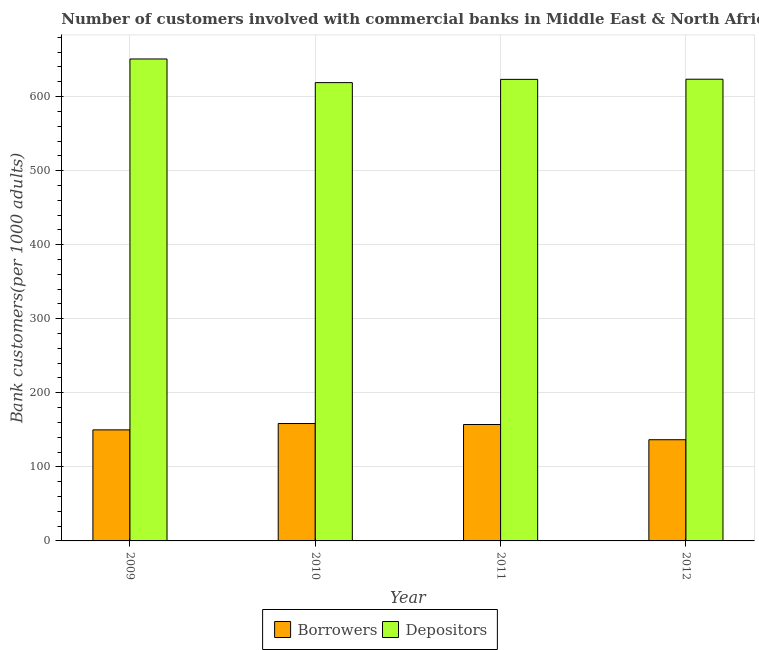Are the number of bars per tick equal to the number of legend labels?
Give a very brief answer. Yes. How many bars are there on the 1st tick from the right?
Give a very brief answer. 2. What is the label of the 3rd group of bars from the left?
Give a very brief answer. 2011. In how many cases, is the number of bars for a given year not equal to the number of legend labels?
Offer a terse response. 0. What is the number of borrowers in 2012?
Provide a short and direct response. 136.65. Across all years, what is the maximum number of borrowers?
Provide a short and direct response. 158.51. Across all years, what is the minimum number of depositors?
Provide a short and direct response. 618.84. What is the total number of borrowers in the graph?
Your answer should be very brief. 602.31. What is the difference between the number of borrowers in 2009 and that in 2011?
Your answer should be very brief. -7.25. What is the difference between the number of borrowers in 2012 and the number of depositors in 2010?
Give a very brief answer. -21.87. What is the average number of depositors per year?
Ensure brevity in your answer.  629.07. In the year 2010, what is the difference between the number of depositors and number of borrowers?
Keep it short and to the point. 0. What is the ratio of the number of depositors in 2010 to that in 2011?
Provide a succinct answer. 0.99. Is the number of borrowers in 2009 less than that in 2012?
Provide a succinct answer. No. Is the difference between the number of borrowers in 2010 and 2011 greater than the difference between the number of depositors in 2010 and 2011?
Offer a very short reply. No. What is the difference between the highest and the second highest number of depositors?
Your answer should be very brief. 27.32. What is the difference between the highest and the lowest number of borrowers?
Your answer should be very brief. 21.87. What does the 1st bar from the left in 2011 represents?
Provide a succinct answer. Borrowers. What does the 2nd bar from the right in 2010 represents?
Your answer should be compact. Borrowers. How many bars are there?
Offer a terse response. 8. What is the difference between two consecutive major ticks on the Y-axis?
Your answer should be very brief. 100. Are the values on the major ticks of Y-axis written in scientific E-notation?
Keep it short and to the point. No. Where does the legend appear in the graph?
Provide a short and direct response. Bottom center. What is the title of the graph?
Ensure brevity in your answer.  Number of customers involved with commercial banks in Middle East & North Africa (all income levels). Does "Highest 10% of population" appear as one of the legend labels in the graph?
Provide a succinct answer. No. What is the label or title of the Y-axis?
Your answer should be very brief. Bank customers(per 1000 adults). What is the Bank customers(per 1000 adults) of Borrowers in 2009?
Provide a succinct answer. 149.95. What is the Bank customers(per 1000 adults) in Depositors in 2009?
Offer a very short reply. 650.77. What is the Bank customers(per 1000 adults) in Borrowers in 2010?
Your answer should be very brief. 158.51. What is the Bank customers(per 1000 adults) of Depositors in 2010?
Provide a short and direct response. 618.84. What is the Bank customers(per 1000 adults) in Borrowers in 2011?
Your response must be concise. 157.2. What is the Bank customers(per 1000 adults) in Depositors in 2011?
Offer a very short reply. 623.22. What is the Bank customers(per 1000 adults) of Borrowers in 2012?
Your answer should be compact. 136.65. What is the Bank customers(per 1000 adults) in Depositors in 2012?
Provide a succinct answer. 623.45. Across all years, what is the maximum Bank customers(per 1000 adults) in Borrowers?
Ensure brevity in your answer.  158.51. Across all years, what is the maximum Bank customers(per 1000 adults) of Depositors?
Ensure brevity in your answer.  650.77. Across all years, what is the minimum Bank customers(per 1000 adults) of Borrowers?
Make the answer very short. 136.65. Across all years, what is the minimum Bank customers(per 1000 adults) of Depositors?
Offer a very short reply. 618.84. What is the total Bank customers(per 1000 adults) in Borrowers in the graph?
Offer a terse response. 602.31. What is the total Bank customers(per 1000 adults) of Depositors in the graph?
Your answer should be compact. 2516.28. What is the difference between the Bank customers(per 1000 adults) of Borrowers in 2009 and that in 2010?
Provide a succinct answer. -8.56. What is the difference between the Bank customers(per 1000 adults) in Depositors in 2009 and that in 2010?
Keep it short and to the point. 31.92. What is the difference between the Bank customers(per 1000 adults) in Borrowers in 2009 and that in 2011?
Offer a very short reply. -7.25. What is the difference between the Bank customers(per 1000 adults) in Depositors in 2009 and that in 2011?
Your answer should be very brief. 27.55. What is the difference between the Bank customers(per 1000 adults) in Borrowers in 2009 and that in 2012?
Your response must be concise. 13.3. What is the difference between the Bank customers(per 1000 adults) in Depositors in 2009 and that in 2012?
Ensure brevity in your answer.  27.32. What is the difference between the Bank customers(per 1000 adults) in Borrowers in 2010 and that in 2011?
Offer a very short reply. 1.32. What is the difference between the Bank customers(per 1000 adults) in Depositors in 2010 and that in 2011?
Your response must be concise. -4.38. What is the difference between the Bank customers(per 1000 adults) of Borrowers in 2010 and that in 2012?
Your answer should be compact. 21.87. What is the difference between the Bank customers(per 1000 adults) of Depositors in 2010 and that in 2012?
Your answer should be very brief. -4.61. What is the difference between the Bank customers(per 1000 adults) in Borrowers in 2011 and that in 2012?
Provide a short and direct response. 20.55. What is the difference between the Bank customers(per 1000 adults) in Depositors in 2011 and that in 2012?
Provide a succinct answer. -0.23. What is the difference between the Bank customers(per 1000 adults) in Borrowers in 2009 and the Bank customers(per 1000 adults) in Depositors in 2010?
Ensure brevity in your answer.  -468.89. What is the difference between the Bank customers(per 1000 adults) in Borrowers in 2009 and the Bank customers(per 1000 adults) in Depositors in 2011?
Offer a very short reply. -473.27. What is the difference between the Bank customers(per 1000 adults) in Borrowers in 2009 and the Bank customers(per 1000 adults) in Depositors in 2012?
Make the answer very short. -473.5. What is the difference between the Bank customers(per 1000 adults) of Borrowers in 2010 and the Bank customers(per 1000 adults) of Depositors in 2011?
Your answer should be very brief. -464.71. What is the difference between the Bank customers(per 1000 adults) in Borrowers in 2010 and the Bank customers(per 1000 adults) in Depositors in 2012?
Provide a succinct answer. -464.93. What is the difference between the Bank customers(per 1000 adults) in Borrowers in 2011 and the Bank customers(per 1000 adults) in Depositors in 2012?
Your answer should be compact. -466.25. What is the average Bank customers(per 1000 adults) in Borrowers per year?
Your answer should be very brief. 150.58. What is the average Bank customers(per 1000 adults) of Depositors per year?
Ensure brevity in your answer.  629.07. In the year 2009, what is the difference between the Bank customers(per 1000 adults) of Borrowers and Bank customers(per 1000 adults) of Depositors?
Provide a short and direct response. -500.82. In the year 2010, what is the difference between the Bank customers(per 1000 adults) in Borrowers and Bank customers(per 1000 adults) in Depositors?
Provide a short and direct response. -460.33. In the year 2011, what is the difference between the Bank customers(per 1000 adults) in Borrowers and Bank customers(per 1000 adults) in Depositors?
Your answer should be very brief. -466.02. In the year 2012, what is the difference between the Bank customers(per 1000 adults) of Borrowers and Bank customers(per 1000 adults) of Depositors?
Provide a short and direct response. -486.8. What is the ratio of the Bank customers(per 1000 adults) in Borrowers in 2009 to that in 2010?
Your answer should be very brief. 0.95. What is the ratio of the Bank customers(per 1000 adults) in Depositors in 2009 to that in 2010?
Provide a succinct answer. 1.05. What is the ratio of the Bank customers(per 1000 adults) of Borrowers in 2009 to that in 2011?
Provide a succinct answer. 0.95. What is the ratio of the Bank customers(per 1000 adults) in Depositors in 2009 to that in 2011?
Provide a succinct answer. 1.04. What is the ratio of the Bank customers(per 1000 adults) of Borrowers in 2009 to that in 2012?
Ensure brevity in your answer.  1.1. What is the ratio of the Bank customers(per 1000 adults) in Depositors in 2009 to that in 2012?
Offer a very short reply. 1.04. What is the ratio of the Bank customers(per 1000 adults) in Borrowers in 2010 to that in 2011?
Provide a short and direct response. 1.01. What is the ratio of the Bank customers(per 1000 adults) in Depositors in 2010 to that in 2011?
Provide a short and direct response. 0.99. What is the ratio of the Bank customers(per 1000 adults) of Borrowers in 2010 to that in 2012?
Make the answer very short. 1.16. What is the ratio of the Bank customers(per 1000 adults) of Borrowers in 2011 to that in 2012?
Offer a terse response. 1.15. What is the ratio of the Bank customers(per 1000 adults) of Depositors in 2011 to that in 2012?
Keep it short and to the point. 1. What is the difference between the highest and the second highest Bank customers(per 1000 adults) of Borrowers?
Offer a very short reply. 1.32. What is the difference between the highest and the second highest Bank customers(per 1000 adults) in Depositors?
Keep it short and to the point. 27.32. What is the difference between the highest and the lowest Bank customers(per 1000 adults) in Borrowers?
Keep it short and to the point. 21.87. What is the difference between the highest and the lowest Bank customers(per 1000 adults) in Depositors?
Keep it short and to the point. 31.92. 